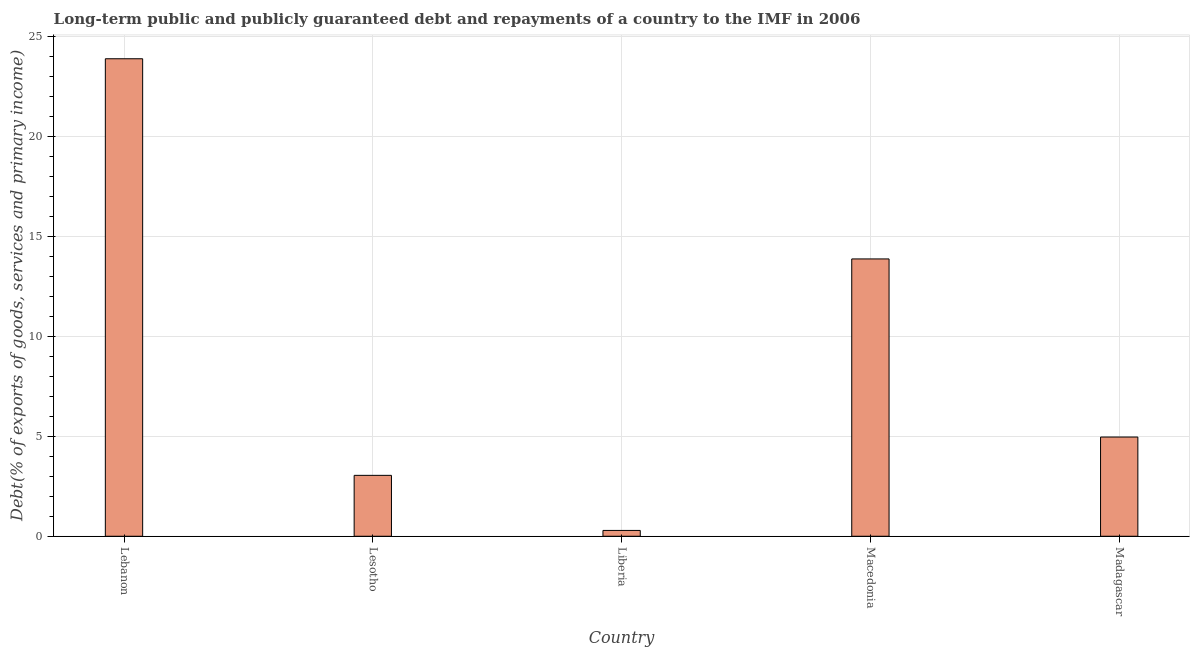Does the graph contain grids?
Offer a terse response. Yes. What is the title of the graph?
Give a very brief answer. Long-term public and publicly guaranteed debt and repayments of a country to the IMF in 2006. What is the label or title of the X-axis?
Keep it short and to the point. Country. What is the label or title of the Y-axis?
Provide a succinct answer. Debt(% of exports of goods, services and primary income). What is the debt service in Lesotho?
Offer a very short reply. 3.04. Across all countries, what is the maximum debt service?
Provide a succinct answer. 23.87. Across all countries, what is the minimum debt service?
Give a very brief answer. 0.29. In which country was the debt service maximum?
Ensure brevity in your answer.  Lebanon. In which country was the debt service minimum?
Your answer should be compact. Liberia. What is the sum of the debt service?
Ensure brevity in your answer.  46.03. What is the difference between the debt service in Liberia and Macedonia?
Give a very brief answer. -13.57. What is the average debt service per country?
Make the answer very short. 9.21. What is the median debt service?
Make the answer very short. 4.96. In how many countries, is the debt service greater than 22 %?
Offer a very short reply. 1. What is the ratio of the debt service in Lesotho to that in Macedonia?
Make the answer very short. 0.22. Is the debt service in Lesotho less than that in Madagascar?
Your answer should be compact. Yes. What is the difference between the highest and the second highest debt service?
Give a very brief answer. 10.01. What is the difference between the highest and the lowest debt service?
Give a very brief answer. 23.58. Are all the bars in the graph horizontal?
Provide a succinct answer. No. What is the difference between two consecutive major ticks on the Y-axis?
Keep it short and to the point. 5. Are the values on the major ticks of Y-axis written in scientific E-notation?
Offer a very short reply. No. What is the Debt(% of exports of goods, services and primary income) in Lebanon?
Your answer should be very brief. 23.87. What is the Debt(% of exports of goods, services and primary income) of Lesotho?
Ensure brevity in your answer.  3.04. What is the Debt(% of exports of goods, services and primary income) in Liberia?
Make the answer very short. 0.29. What is the Debt(% of exports of goods, services and primary income) in Macedonia?
Provide a succinct answer. 13.86. What is the Debt(% of exports of goods, services and primary income) of Madagascar?
Ensure brevity in your answer.  4.96. What is the difference between the Debt(% of exports of goods, services and primary income) in Lebanon and Lesotho?
Offer a terse response. 20.83. What is the difference between the Debt(% of exports of goods, services and primary income) in Lebanon and Liberia?
Offer a terse response. 23.58. What is the difference between the Debt(% of exports of goods, services and primary income) in Lebanon and Macedonia?
Provide a succinct answer. 10.01. What is the difference between the Debt(% of exports of goods, services and primary income) in Lebanon and Madagascar?
Give a very brief answer. 18.91. What is the difference between the Debt(% of exports of goods, services and primary income) in Lesotho and Liberia?
Your answer should be compact. 2.75. What is the difference between the Debt(% of exports of goods, services and primary income) in Lesotho and Macedonia?
Ensure brevity in your answer.  -10.82. What is the difference between the Debt(% of exports of goods, services and primary income) in Lesotho and Madagascar?
Ensure brevity in your answer.  -1.92. What is the difference between the Debt(% of exports of goods, services and primary income) in Liberia and Macedonia?
Give a very brief answer. -13.57. What is the difference between the Debt(% of exports of goods, services and primary income) in Liberia and Madagascar?
Your answer should be very brief. -4.67. What is the difference between the Debt(% of exports of goods, services and primary income) in Macedonia and Madagascar?
Give a very brief answer. 8.9. What is the ratio of the Debt(% of exports of goods, services and primary income) in Lebanon to that in Lesotho?
Your answer should be very brief. 7.84. What is the ratio of the Debt(% of exports of goods, services and primary income) in Lebanon to that in Liberia?
Offer a very short reply. 81.93. What is the ratio of the Debt(% of exports of goods, services and primary income) in Lebanon to that in Macedonia?
Your answer should be compact. 1.72. What is the ratio of the Debt(% of exports of goods, services and primary income) in Lebanon to that in Madagascar?
Offer a very short reply. 4.81. What is the ratio of the Debt(% of exports of goods, services and primary income) in Lesotho to that in Liberia?
Make the answer very short. 10.45. What is the ratio of the Debt(% of exports of goods, services and primary income) in Lesotho to that in Macedonia?
Offer a very short reply. 0.22. What is the ratio of the Debt(% of exports of goods, services and primary income) in Lesotho to that in Madagascar?
Your answer should be very brief. 0.61. What is the ratio of the Debt(% of exports of goods, services and primary income) in Liberia to that in Macedonia?
Your answer should be compact. 0.02. What is the ratio of the Debt(% of exports of goods, services and primary income) in Liberia to that in Madagascar?
Provide a short and direct response. 0.06. What is the ratio of the Debt(% of exports of goods, services and primary income) in Macedonia to that in Madagascar?
Provide a short and direct response. 2.79. 